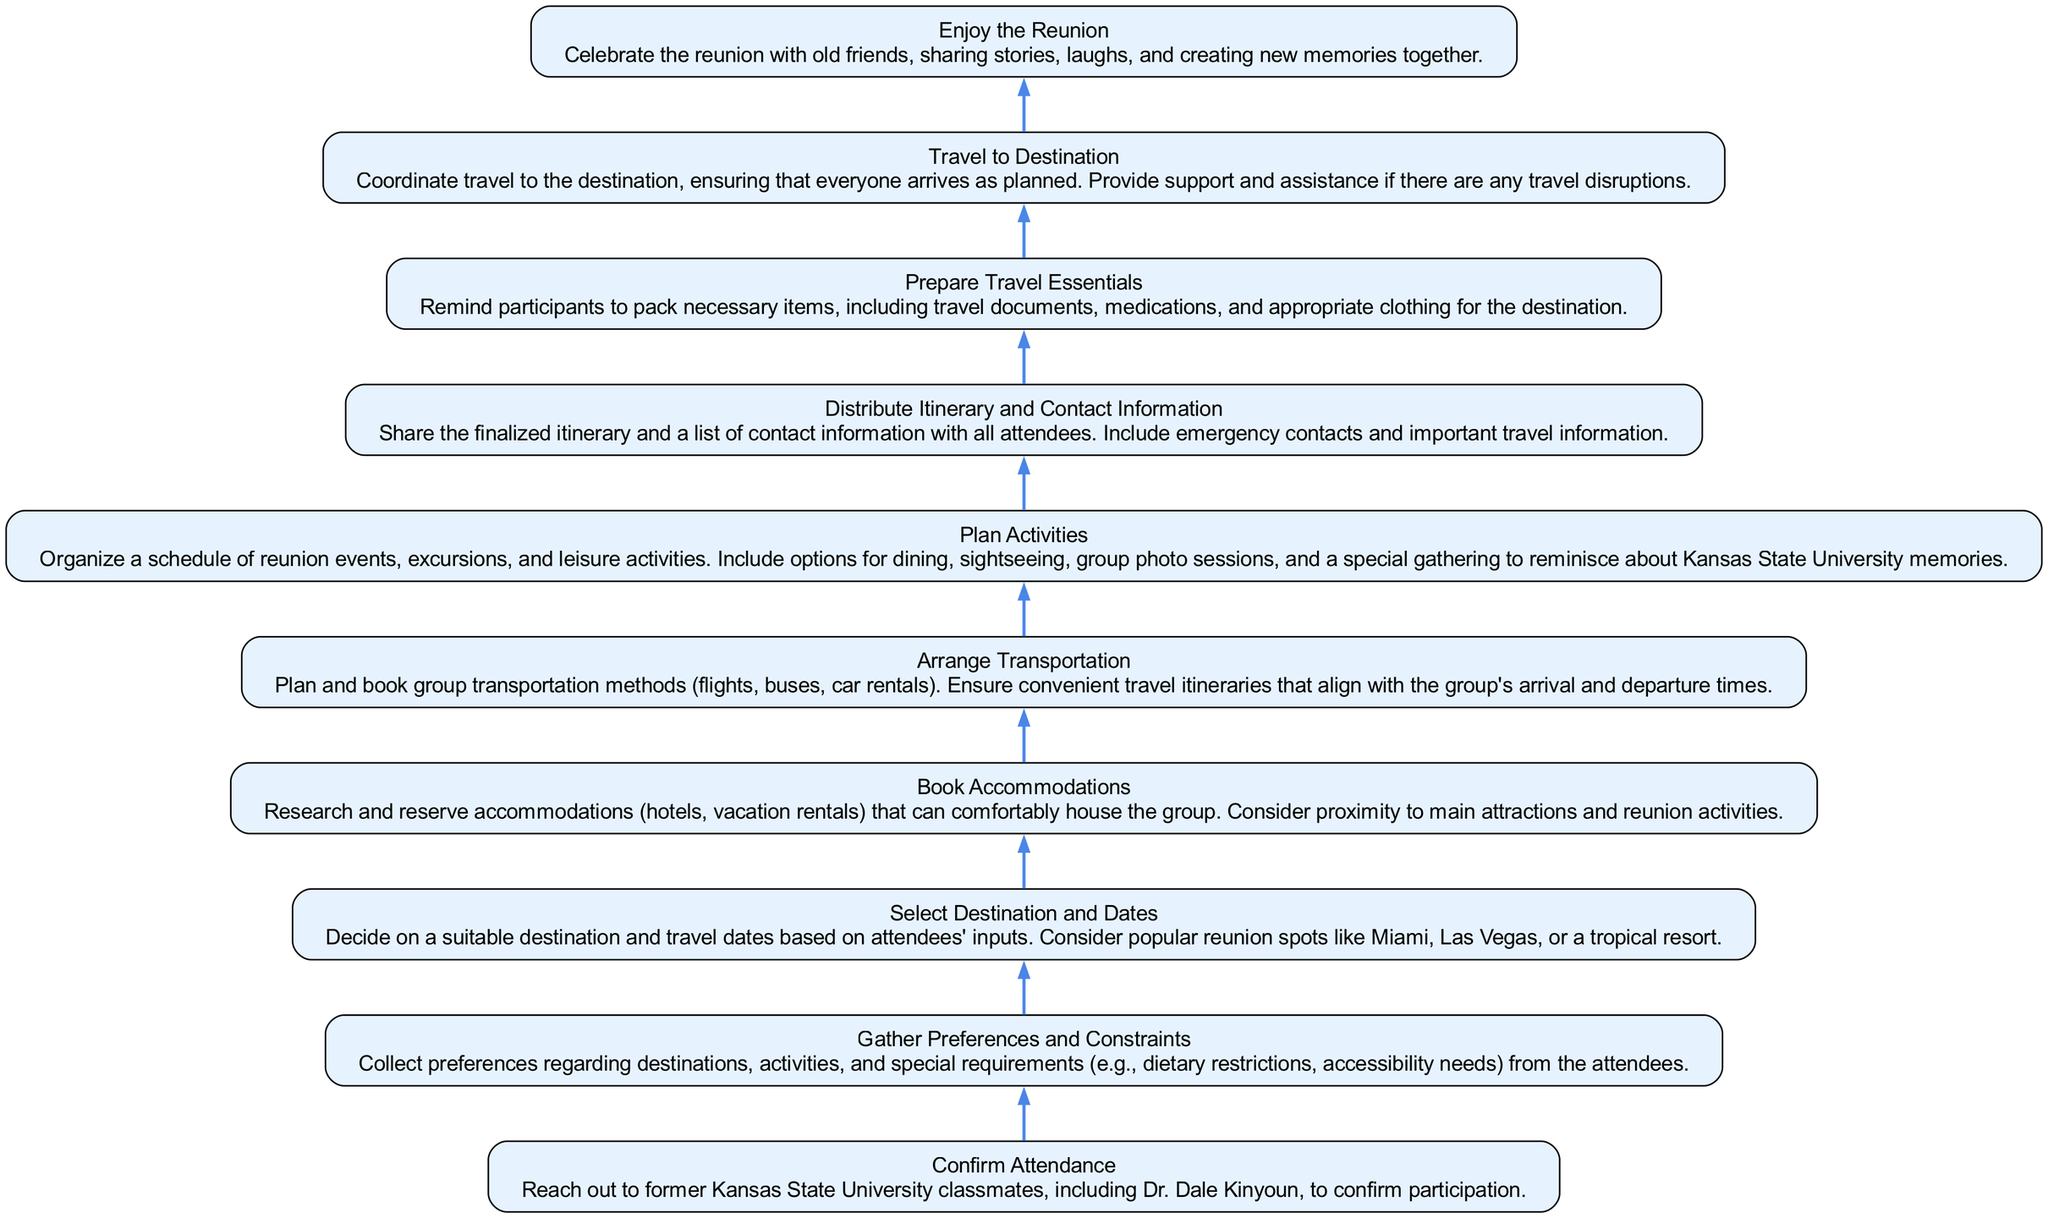What is the first step in the travel plan? The first step is "Confirm Attendance," which is indicated at the bottom of the flow chart. This step involves reaching out to old classmates, including Dr. Dale Kinyoun, to confirm their participation in the reunion.
Answer: Confirm Attendance How many total steps are in the diagram? By counting the steps represented as nodes in the flow chart, there are ten distinct steps outlined in the plan. Each step represents a key action within the travel planning process.
Answer: 10 What step occurs after "Arrange Transportation"? Following "Arrange Transportation," the next step in the flow chart is "Plan Activities." This means that once transportation is organized, the next focus is on scheduling the reunion events and activities.
Answer: Plan Activities Which step involves sharing contact information? The step that involves sharing contact information is "Distribute Itinerary and Contact Information." This step ensures that all attendees have access to essential travel details and emergency contacts.
Answer: Distribute Itinerary and Contact Information Which two steps directly precede "Enjoy the Reunion"? "Travel to Destination" and "Prepare Travel Essentials" are the two steps directly preceding "Enjoy the Reunion." This indicates that ensuring participants are prepared for travel and have arrived is crucial before the actual reunion festivities.
Answer: Travel to Destination and Prepare Travel Essentials What type of items should participants pack according to the diagram? Participants are reminded to pack "necessary items, including travel documents, medications, and appropriate clothing for the destination." This ensures they are well-prepared for the trip.
Answer: Necessary items What is the purpose of the step "Gather Preferences and Constraints"? The purpose of "Gather Preferences and Constraints" is to collect information regarding the attendees’ preferences for destinations, activities, and any special requirements. This is critical for making informed decisions about the reunion.
Answer: Collect preferences How does the flow of the diagram proceed from planning activities to distributing information? The flow moves from "Plan Activities," where scheduling occurs, to "Distribute Itinerary and Contact Information." After planning the activities, it is essential to communicate that information effectively to all attendees to ensure everyone is informed.
Answer: Itinerary communication 